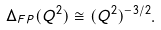<formula> <loc_0><loc_0><loc_500><loc_500>\Delta _ { F P } ( Q ^ { 2 } ) \cong ( Q ^ { 2 } ) ^ { - 3 / 2 } .</formula> 